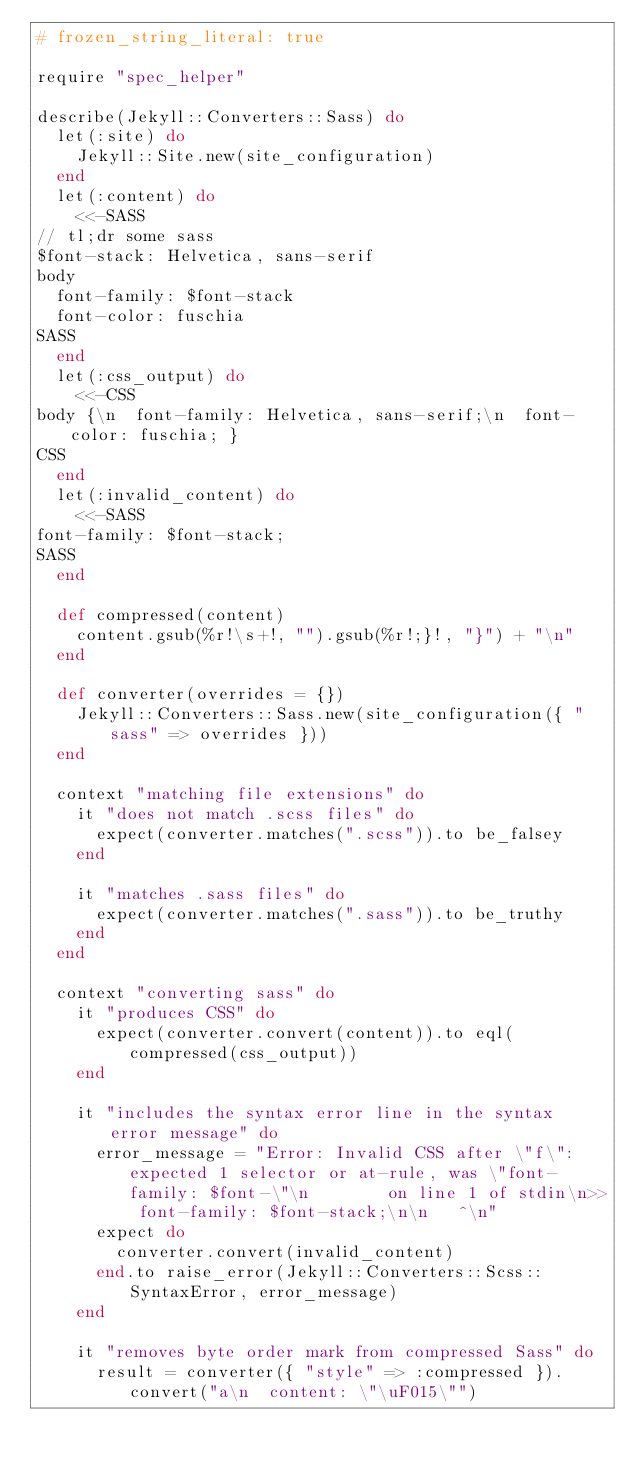Convert code to text. <code><loc_0><loc_0><loc_500><loc_500><_Ruby_># frozen_string_literal: true

require "spec_helper"

describe(Jekyll::Converters::Sass) do
  let(:site) do
    Jekyll::Site.new(site_configuration)
  end
  let(:content) do
    <<-SASS
// tl;dr some sass
$font-stack: Helvetica, sans-serif
body
  font-family: $font-stack
  font-color: fuschia
SASS
  end
  let(:css_output) do
    <<-CSS
body {\n  font-family: Helvetica, sans-serif;\n  font-color: fuschia; }
CSS
  end
  let(:invalid_content) do
    <<-SASS
font-family: $font-stack;
SASS
  end

  def compressed(content)
    content.gsub(%r!\s+!, "").gsub(%r!;}!, "}") + "\n"
  end

  def converter(overrides = {})
    Jekyll::Converters::Sass.new(site_configuration({ "sass" => overrides }))
  end

  context "matching file extensions" do
    it "does not match .scss files" do
      expect(converter.matches(".scss")).to be_falsey
    end

    it "matches .sass files" do
      expect(converter.matches(".sass")).to be_truthy
    end
  end

  context "converting sass" do
    it "produces CSS" do
      expect(converter.convert(content)).to eql(compressed(css_output))
    end

    it "includes the syntax error line in the syntax error message" do
      error_message = "Error: Invalid CSS after \"f\": expected 1 selector or at-rule, was \"font-family: $font-\"\n        on line 1 of stdin\n>> font-family: $font-stack;\n\n   ^\n"
      expect do
        converter.convert(invalid_content)
      end.to raise_error(Jekyll::Converters::Scss::SyntaxError, error_message)
    end

    it "removes byte order mark from compressed Sass" do
      result = converter({ "style" => :compressed }).convert("a\n  content: \"\uF015\"")</code> 